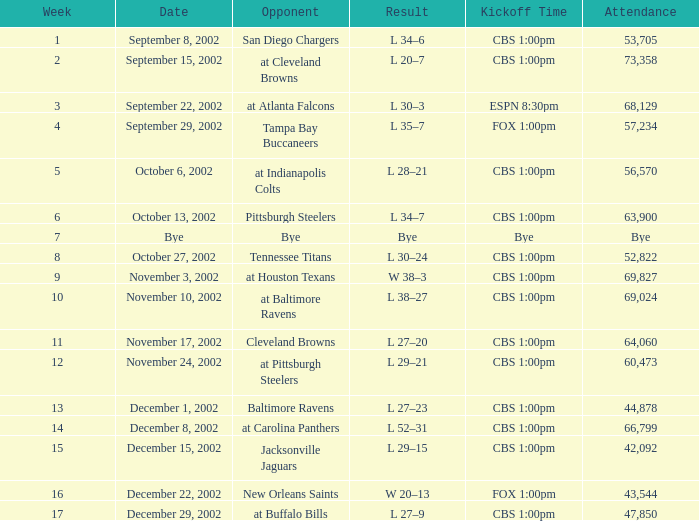What is the kickoff time for the game in week of 17? CBS 1:00pm. 